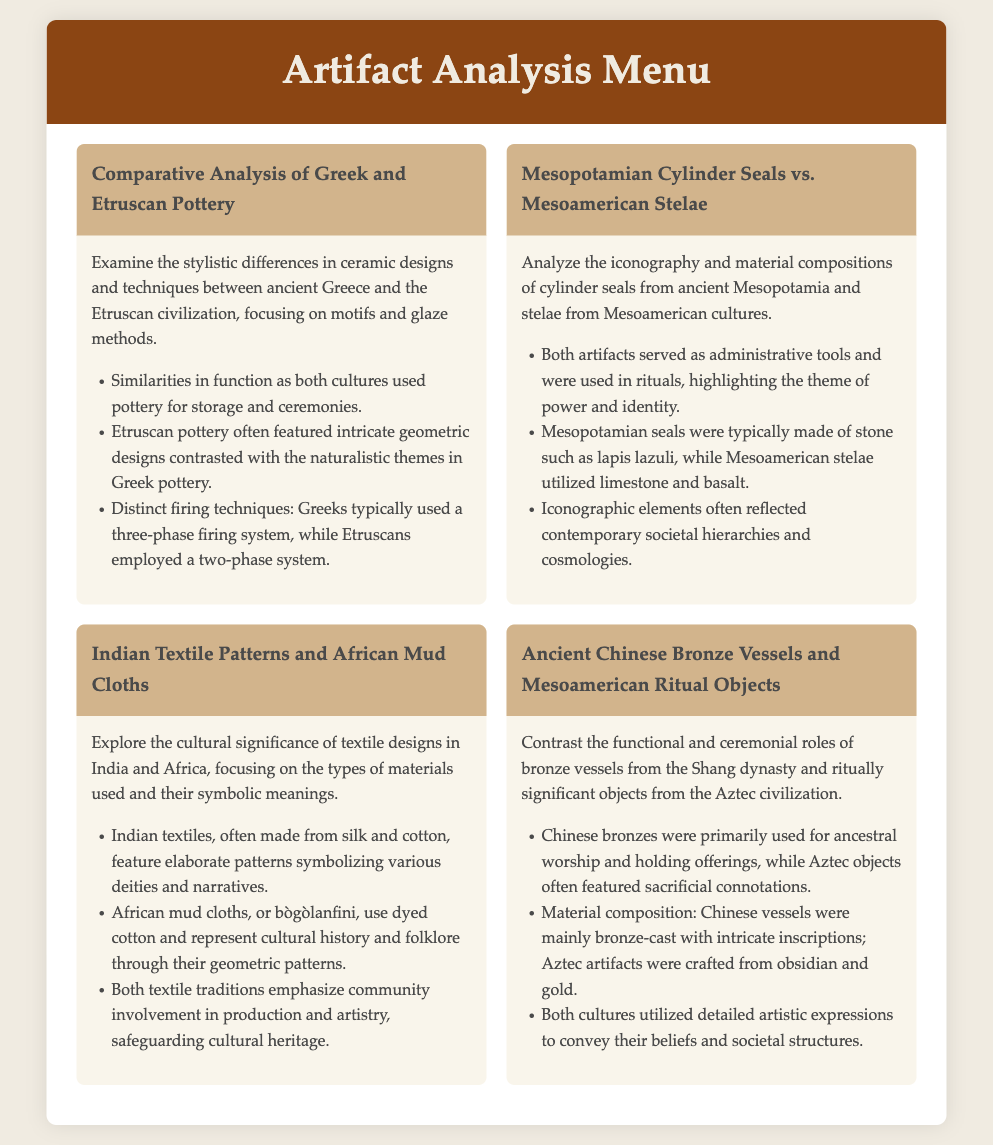What are the two cultures compared in the first analysis? The first analysis compares ancient Greece and the Etruscan civilization regarding pottery.
Answer: Greek and Etruscan Which material was typically used for Mesopotamian cylinder seals? The document states that Mesopotamian cylinder seals were typically made of stone such as lapis lazuli.
Answer: Lapis lazuli What type of textile is often made from silk and cotton? The document mentions that Indian textiles are often made from silk and cotton featuring elaborate patterns.
Answer: Indian textiles What primary purpose do ancient Chinese bronze vessels serve? The document indicates that bronze vessels from the Shang dynasty were primarily used for ancestral worship and holding offerings.
Answer: Ancestral worship What symbolizes cultural history and folklore in African mud cloths? According to the document, African mud cloths represent cultural history and folklore through their geometric patterns.
Answer: Geometric patterns What significant ritual is associated with Aztec objects? The document notes that Aztec artifacts often featured sacrificial connotations.
Answer: Sacrificial What is a common theme in the functions of cylinder seals and stelae? Both artifacts served as administrative tools and were used in rituals, highlighting the theme of power and identity.
Answer: Power and identity How many phases of firing are typically used in Etruscan pottery? The document states that Etruscan pottery employed a two-phase firing system.
Answer: Two-phase Which civilizations' artifacts are contrasted in the last menu item? The last menu item contrasts artifacts from the Shang dynasty and the Aztec civilization.
Answer: Shang dynasty and Aztec 